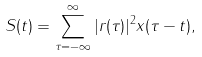Convert formula to latex. <formula><loc_0><loc_0><loc_500><loc_500>S ( t ) = \sum _ { \tau = - \infty } ^ { \infty } | r ( \tau ) | ^ { 2 } x ( \tau - t ) ,</formula> 